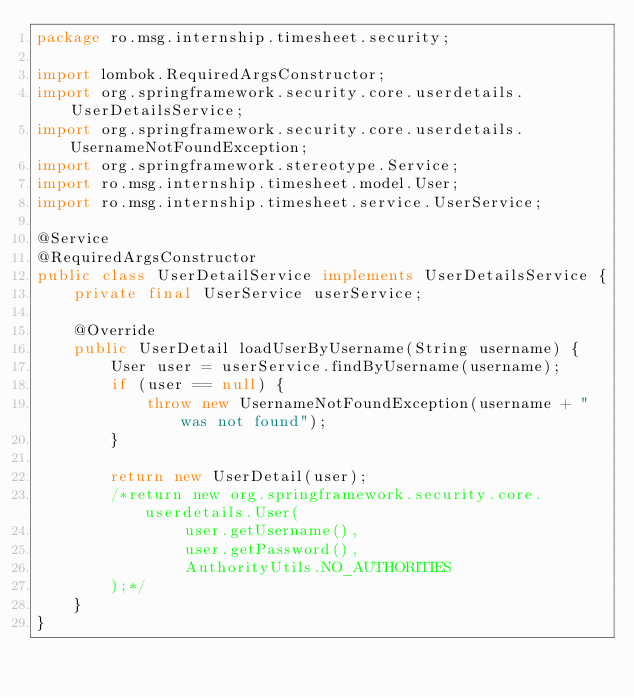<code> <loc_0><loc_0><loc_500><loc_500><_Java_>package ro.msg.internship.timesheet.security;

import lombok.RequiredArgsConstructor;
import org.springframework.security.core.userdetails.UserDetailsService;
import org.springframework.security.core.userdetails.UsernameNotFoundException;
import org.springframework.stereotype.Service;
import ro.msg.internship.timesheet.model.User;
import ro.msg.internship.timesheet.service.UserService;

@Service
@RequiredArgsConstructor
public class UserDetailService implements UserDetailsService {
    private final UserService userService;

    @Override
    public UserDetail loadUserByUsername(String username) {
        User user = userService.findByUsername(username);
        if (user == null) {
            throw new UsernameNotFoundException(username + " was not found");
        }

        return new UserDetail(user);
        /*return new org.springframework.security.core.userdetails.User(
                user.getUsername(),
                user.getPassword(),
                AuthorityUtils.NO_AUTHORITIES
        );*/
    }
}
</code> 